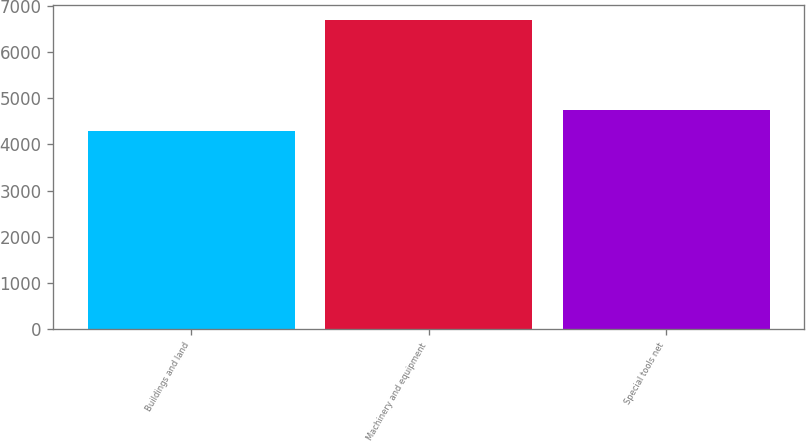<chart> <loc_0><loc_0><loc_500><loc_500><bar_chart><fcel>Buildings and land<fcel>Machinery and equipment<fcel>Special tools net<nl><fcel>4292<fcel>6686<fcel>4743<nl></chart> 